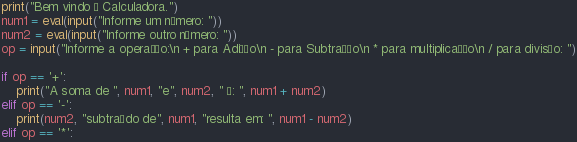Convert code to text. <code><loc_0><loc_0><loc_500><loc_500><_Python_>print("Bem vindo à Calculadora.")
num1 = eval(input("Informe um número: "))
num2 = eval(input("Informe outro número: "))
op = input("Informe a operação:\n + para Adição\n - para Subtração\n * para multiplicação\n / para divisão: ")

if op == '+':
    print("A soma de ", num1, "e", num2, " é: ", num1 + num2)
elif op == '-':
    print(num2, "subtraído de", num1, "resulta em: ", num1 - num2)
elif op == '*':</code> 